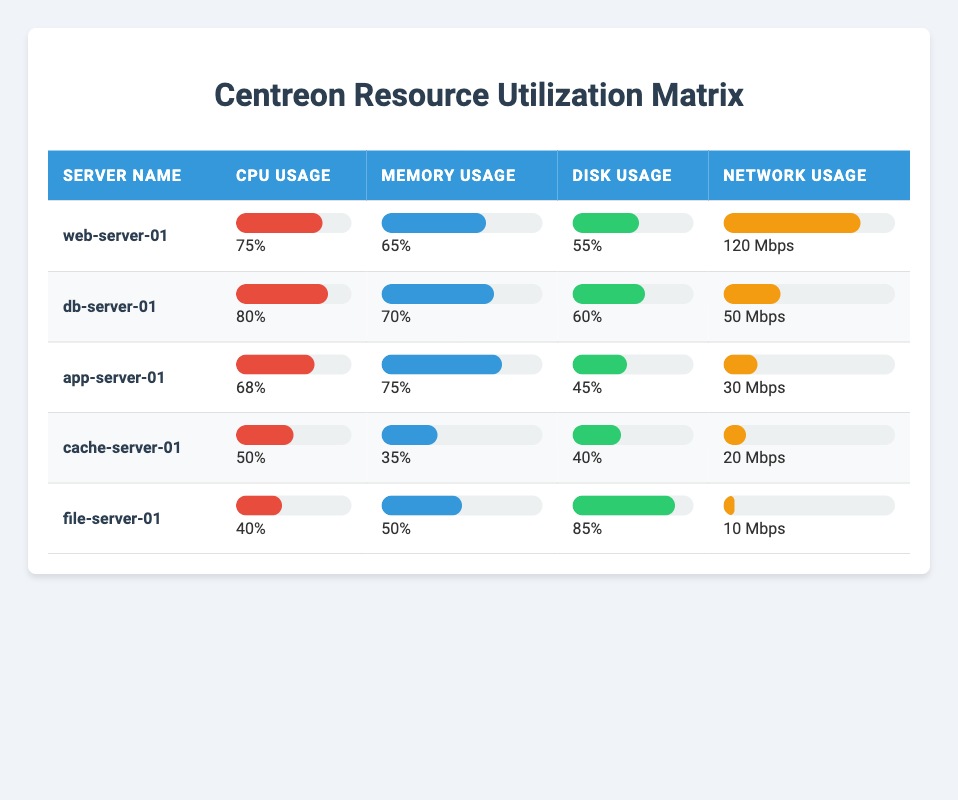What is the CPU usage percentage of db-server-01? The table lists the CPU usage percentage for each server. For db-server-01, the CPU usage is directly mentioned as 80%.
Answer: 80% Which server has the lowest memory usage percentage? To find the server with the lowest memory usage, we compare the memory usage percentages: web-server-01 (65%), db-server-01 (70%), app-server-01 (75%), cache-server-01 (35%), and file-server-01 (50%). The lowest is from cache-server-01 at 35%.
Answer: cache-server-01 What is the average disk usage percentage across all servers? We calculate the average by adding the disk usage percentages (55 + 60 + 45 + 40 + 85 = 285) and dividing by the number of servers (5). The average is 285 / 5 = 57%.
Answer: 57% Is the network usage of app-server-01 greater than that of cache-server-01? For app-server-01, the network usage is 30 Mbps, while for cache-server-01, it is 20 Mbps. Since 30 is greater than 20, the answer is yes.
Answer: Yes Which server has the highest combined resource usage (CPU, Memory, Disk, and Network)? We calculate the combined usage for each server: web-server-01 (75 + 65 + 55 + 120 = 315), db-server-01 (80 + 70 + 60 + 50 = 260), app-server-01 (68 + 75 + 45 + 30 = 218), cache-server-01 (50 + 35 + 40 + 20 = 145), file-server-01 (40 + 50 + 85 + 10 = 185). The highest combined usage is from web-server-01 at 315.
Answer: web-server-01 Which servers have CPU usage greater than 70%? We look at the CPU usage percentages: web-server-01 (75%), db-server-01 (80%), app-server-01 (68%), cache-server-01 (50%), file-server-01 (40%). The servers with CPU usage greater than 70% are web-server-01 and db-server-01.
Answer: web-server-01, db-server-01 What is the difference in network usage between file-server-01 and db-server-01? The network usage for file-server-01 is 10 Mbps and for db-server-01 is 50 Mbps. The difference is calculated by subtracting these values: 50 - 10 = 40 Mbps.
Answer: 40 Mbps 